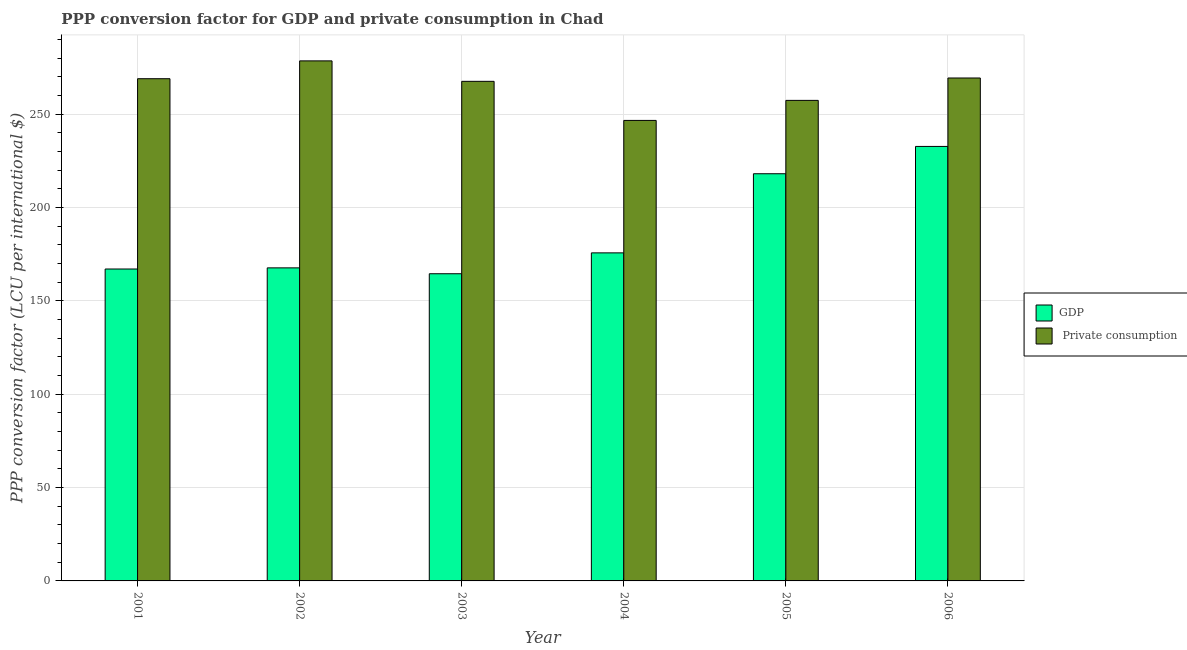How many groups of bars are there?
Provide a succinct answer. 6. Are the number of bars per tick equal to the number of legend labels?
Provide a short and direct response. Yes. How many bars are there on the 5th tick from the right?
Offer a terse response. 2. What is the label of the 1st group of bars from the left?
Offer a very short reply. 2001. What is the ppp conversion factor for gdp in 2005?
Give a very brief answer. 218.09. Across all years, what is the maximum ppp conversion factor for gdp?
Offer a very short reply. 232.72. Across all years, what is the minimum ppp conversion factor for gdp?
Ensure brevity in your answer.  164.53. In which year was the ppp conversion factor for private consumption minimum?
Ensure brevity in your answer.  2004. What is the total ppp conversion factor for gdp in the graph?
Provide a short and direct response. 1125.79. What is the difference between the ppp conversion factor for private consumption in 2001 and that in 2006?
Provide a succinct answer. -0.38. What is the difference between the ppp conversion factor for private consumption in 2003 and the ppp conversion factor for gdp in 2006?
Your answer should be very brief. -1.79. What is the average ppp conversion factor for gdp per year?
Offer a terse response. 187.63. In the year 2001, what is the difference between the ppp conversion factor for private consumption and ppp conversion factor for gdp?
Make the answer very short. 0. In how many years, is the ppp conversion factor for private consumption greater than 270 LCU?
Offer a terse response. 1. What is the ratio of the ppp conversion factor for gdp in 2004 to that in 2005?
Keep it short and to the point. 0.81. Is the ppp conversion factor for gdp in 2005 less than that in 2006?
Make the answer very short. Yes. What is the difference between the highest and the second highest ppp conversion factor for gdp?
Ensure brevity in your answer.  14.63. What is the difference between the highest and the lowest ppp conversion factor for gdp?
Your answer should be compact. 68.19. What does the 1st bar from the left in 2005 represents?
Give a very brief answer. GDP. What does the 1st bar from the right in 2006 represents?
Your response must be concise.  Private consumption. Are the values on the major ticks of Y-axis written in scientific E-notation?
Offer a terse response. No. Where does the legend appear in the graph?
Your response must be concise. Center right. How many legend labels are there?
Your answer should be very brief. 2. What is the title of the graph?
Provide a short and direct response. PPP conversion factor for GDP and private consumption in Chad. What is the label or title of the Y-axis?
Provide a short and direct response. PPP conversion factor (LCU per international $). What is the PPP conversion factor (LCU per international $) in GDP in 2001?
Offer a terse response. 167.06. What is the PPP conversion factor (LCU per international $) of  Private consumption in 2001?
Your answer should be very brief. 269. What is the PPP conversion factor (LCU per international $) of GDP in 2002?
Offer a very short reply. 167.68. What is the PPP conversion factor (LCU per international $) in  Private consumption in 2002?
Provide a succinct answer. 278.54. What is the PPP conversion factor (LCU per international $) in GDP in 2003?
Give a very brief answer. 164.53. What is the PPP conversion factor (LCU per international $) in  Private consumption in 2003?
Your response must be concise. 267.59. What is the PPP conversion factor (LCU per international $) of GDP in 2004?
Give a very brief answer. 175.71. What is the PPP conversion factor (LCU per international $) of  Private consumption in 2004?
Your answer should be compact. 246.65. What is the PPP conversion factor (LCU per international $) in GDP in 2005?
Offer a very short reply. 218.09. What is the PPP conversion factor (LCU per international $) of  Private consumption in 2005?
Offer a very short reply. 257.38. What is the PPP conversion factor (LCU per international $) in GDP in 2006?
Make the answer very short. 232.72. What is the PPP conversion factor (LCU per international $) of  Private consumption in 2006?
Your answer should be very brief. 269.38. Across all years, what is the maximum PPP conversion factor (LCU per international $) of GDP?
Your answer should be very brief. 232.72. Across all years, what is the maximum PPP conversion factor (LCU per international $) of  Private consumption?
Make the answer very short. 278.54. Across all years, what is the minimum PPP conversion factor (LCU per international $) of GDP?
Offer a very short reply. 164.53. Across all years, what is the minimum PPP conversion factor (LCU per international $) in  Private consumption?
Your answer should be compact. 246.65. What is the total PPP conversion factor (LCU per international $) of GDP in the graph?
Offer a terse response. 1125.79. What is the total PPP conversion factor (LCU per international $) in  Private consumption in the graph?
Your response must be concise. 1588.54. What is the difference between the PPP conversion factor (LCU per international $) in GDP in 2001 and that in 2002?
Offer a terse response. -0.61. What is the difference between the PPP conversion factor (LCU per international $) in  Private consumption in 2001 and that in 2002?
Your answer should be compact. -9.55. What is the difference between the PPP conversion factor (LCU per international $) in GDP in 2001 and that in 2003?
Your answer should be very brief. 2.54. What is the difference between the PPP conversion factor (LCU per international $) in  Private consumption in 2001 and that in 2003?
Ensure brevity in your answer.  1.41. What is the difference between the PPP conversion factor (LCU per international $) in GDP in 2001 and that in 2004?
Your answer should be compact. -8.65. What is the difference between the PPP conversion factor (LCU per international $) in  Private consumption in 2001 and that in 2004?
Provide a short and direct response. 22.34. What is the difference between the PPP conversion factor (LCU per international $) in GDP in 2001 and that in 2005?
Give a very brief answer. -51.03. What is the difference between the PPP conversion factor (LCU per international $) in  Private consumption in 2001 and that in 2005?
Keep it short and to the point. 11.61. What is the difference between the PPP conversion factor (LCU per international $) in GDP in 2001 and that in 2006?
Offer a terse response. -65.65. What is the difference between the PPP conversion factor (LCU per international $) of  Private consumption in 2001 and that in 2006?
Keep it short and to the point. -0.38. What is the difference between the PPP conversion factor (LCU per international $) in GDP in 2002 and that in 2003?
Offer a terse response. 3.15. What is the difference between the PPP conversion factor (LCU per international $) of  Private consumption in 2002 and that in 2003?
Your response must be concise. 10.96. What is the difference between the PPP conversion factor (LCU per international $) of GDP in 2002 and that in 2004?
Give a very brief answer. -8.04. What is the difference between the PPP conversion factor (LCU per international $) of  Private consumption in 2002 and that in 2004?
Provide a short and direct response. 31.89. What is the difference between the PPP conversion factor (LCU per international $) in GDP in 2002 and that in 2005?
Give a very brief answer. -50.41. What is the difference between the PPP conversion factor (LCU per international $) of  Private consumption in 2002 and that in 2005?
Your answer should be very brief. 21.16. What is the difference between the PPP conversion factor (LCU per international $) in GDP in 2002 and that in 2006?
Ensure brevity in your answer.  -65.04. What is the difference between the PPP conversion factor (LCU per international $) in  Private consumption in 2002 and that in 2006?
Your answer should be compact. 9.17. What is the difference between the PPP conversion factor (LCU per international $) in GDP in 2003 and that in 2004?
Offer a terse response. -11.18. What is the difference between the PPP conversion factor (LCU per international $) in  Private consumption in 2003 and that in 2004?
Keep it short and to the point. 20.93. What is the difference between the PPP conversion factor (LCU per international $) in GDP in 2003 and that in 2005?
Keep it short and to the point. -53.56. What is the difference between the PPP conversion factor (LCU per international $) in  Private consumption in 2003 and that in 2005?
Keep it short and to the point. 10.2. What is the difference between the PPP conversion factor (LCU per international $) of GDP in 2003 and that in 2006?
Provide a succinct answer. -68.19. What is the difference between the PPP conversion factor (LCU per international $) of  Private consumption in 2003 and that in 2006?
Give a very brief answer. -1.79. What is the difference between the PPP conversion factor (LCU per international $) of GDP in 2004 and that in 2005?
Ensure brevity in your answer.  -42.38. What is the difference between the PPP conversion factor (LCU per international $) in  Private consumption in 2004 and that in 2005?
Keep it short and to the point. -10.73. What is the difference between the PPP conversion factor (LCU per international $) of GDP in 2004 and that in 2006?
Offer a terse response. -57. What is the difference between the PPP conversion factor (LCU per international $) in  Private consumption in 2004 and that in 2006?
Give a very brief answer. -22.72. What is the difference between the PPP conversion factor (LCU per international $) in GDP in 2005 and that in 2006?
Offer a terse response. -14.63. What is the difference between the PPP conversion factor (LCU per international $) in  Private consumption in 2005 and that in 2006?
Offer a very short reply. -11.99. What is the difference between the PPP conversion factor (LCU per international $) of GDP in 2001 and the PPP conversion factor (LCU per international $) of  Private consumption in 2002?
Ensure brevity in your answer.  -111.48. What is the difference between the PPP conversion factor (LCU per international $) of GDP in 2001 and the PPP conversion factor (LCU per international $) of  Private consumption in 2003?
Provide a succinct answer. -100.52. What is the difference between the PPP conversion factor (LCU per international $) of GDP in 2001 and the PPP conversion factor (LCU per international $) of  Private consumption in 2004?
Keep it short and to the point. -79.59. What is the difference between the PPP conversion factor (LCU per international $) in GDP in 2001 and the PPP conversion factor (LCU per international $) in  Private consumption in 2005?
Offer a terse response. -90.32. What is the difference between the PPP conversion factor (LCU per international $) in GDP in 2001 and the PPP conversion factor (LCU per international $) in  Private consumption in 2006?
Offer a very short reply. -102.31. What is the difference between the PPP conversion factor (LCU per international $) of GDP in 2002 and the PPP conversion factor (LCU per international $) of  Private consumption in 2003?
Your answer should be compact. -99.91. What is the difference between the PPP conversion factor (LCU per international $) in GDP in 2002 and the PPP conversion factor (LCU per international $) in  Private consumption in 2004?
Give a very brief answer. -78.98. What is the difference between the PPP conversion factor (LCU per international $) of GDP in 2002 and the PPP conversion factor (LCU per international $) of  Private consumption in 2005?
Your answer should be very brief. -89.71. What is the difference between the PPP conversion factor (LCU per international $) of GDP in 2002 and the PPP conversion factor (LCU per international $) of  Private consumption in 2006?
Offer a terse response. -101.7. What is the difference between the PPP conversion factor (LCU per international $) in GDP in 2003 and the PPP conversion factor (LCU per international $) in  Private consumption in 2004?
Give a very brief answer. -82.12. What is the difference between the PPP conversion factor (LCU per international $) in GDP in 2003 and the PPP conversion factor (LCU per international $) in  Private consumption in 2005?
Offer a terse response. -92.85. What is the difference between the PPP conversion factor (LCU per international $) of GDP in 2003 and the PPP conversion factor (LCU per international $) of  Private consumption in 2006?
Your answer should be very brief. -104.85. What is the difference between the PPP conversion factor (LCU per international $) in GDP in 2004 and the PPP conversion factor (LCU per international $) in  Private consumption in 2005?
Your answer should be very brief. -81.67. What is the difference between the PPP conversion factor (LCU per international $) of GDP in 2004 and the PPP conversion factor (LCU per international $) of  Private consumption in 2006?
Offer a very short reply. -93.66. What is the difference between the PPP conversion factor (LCU per international $) of GDP in 2005 and the PPP conversion factor (LCU per international $) of  Private consumption in 2006?
Ensure brevity in your answer.  -51.29. What is the average PPP conversion factor (LCU per international $) in GDP per year?
Offer a very short reply. 187.63. What is the average PPP conversion factor (LCU per international $) in  Private consumption per year?
Make the answer very short. 264.76. In the year 2001, what is the difference between the PPP conversion factor (LCU per international $) of GDP and PPP conversion factor (LCU per international $) of  Private consumption?
Your response must be concise. -101.93. In the year 2002, what is the difference between the PPP conversion factor (LCU per international $) of GDP and PPP conversion factor (LCU per international $) of  Private consumption?
Ensure brevity in your answer.  -110.87. In the year 2003, what is the difference between the PPP conversion factor (LCU per international $) in GDP and PPP conversion factor (LCU per international $) in  Private consumption?
Offer a very short reply. -103.06. In the year 2004, what is the difference between the PPP conversion factor (LCU per international $) of GDP and PPP conversion factor (LCU per international $) of  Private consumption?
Your response must be concise. -70.94. In the year 2005, what is the difference between the PPP conversion factor (LCU per international $) in GDP and PPP conversion factor (LCU per international $) in  Private consumption?
Offer a very short reply. -39.29. In the year 2006, what is the difference between the PPP conversion factor (LCU per international $) of GDP and PPP conversion factor (LCU per international $) of  Private consumption?
Your answer should be very brief. -36.66. What is the ratio of the PPP conversion factor (LCU per international $) in  Private consumption in 2001 to that in 2002?
Offer a very short reply. 0.97. What is the ratio of the PPP conversion factor (LCU per international $) of GDP in 2001 to that in 2003?
Provide a succinct answer. 1.02. What is the ratio of the PPP conversion factor (LCU per international $) in  Private consumption in 2001 to that in 2003?
Make the answer very short. 1.01. What is the ratio of the PPP conversion factor (LCU per international $) of GDP in 2001 to that in 2004?
Your answer should be very brief. 0.95. What is the ratio of the PPP conversion factor (LCU per international $) in  Private consumption in 2001 to that in 2004?
Offer a very short reply. 1.09. What is the ratio of the PPP conversion factor (LCU per international $) in GDP in 2001 to that in 2005?
Provide a succinct answer. 0.77. What is the ratio of the PPP conversion factor (LCU per international $) of  Private consumption in 2001 to that in 2005?
Your response must be concise. 1.05. What is the ratio of the PPP conversion factor (LCU per international $) of GDP in 2001 to that in 2006?
Ensure brevity in your answer.  0.72. What is the ratio of the PPP conversion factor (LCU per international $) of  Private consumption in 2001 to that in 2006?
Provide a succinct answer. 1. What is the ratio of the PPP conversion factor (LCU per international $) of GDP in 2002 to that in 2003?
Ensure brevity in your answer.  1.02. What is the ratio of the PPP conversion factor (LCU per international $) in  Private consumption in 2002 to that in 2003?
Make the answer very short. 1.04. What is the ratio of the PPP conversion factor (LCU per international $) in GDP in 2002 to that in 2004?
Give a very brief answer. 0.95. What is the ratio of the PPP conversion factor (LCU per international $) of  Private consumption in 2002 to that in 2004?
Your response must be concise. 1.13. What is the ratio of the PPP conversion factor (LCU per international $) of GDP in 2002 to that in 2005?
Keep it short and to the point. 0.77. What is the ratio of the PPP conversion factor (LCU per international $) of  Private consumption in 2002 to that in 2005?
Keep it short and to the point. 1.08. What is the ratio of the PPP conversion factor (LCU per international $) in GDP in 2002 to that in 2006?
Keep it short and to the point. 0.72. What is the ratio of the PPP conversion factor (LCU per international $) in  Private consumption in 2002 to that in 2006?
Provide a short and direct response. 1.03. What is the ratio of the PPP conversion factor (LCU per international $) of GDP in 2003 to that in 2004?
Offer a terse response. 0.94. What is the ratio of the PPP conversion factor (LCU per international $) in  Private consumption in 2003 to that in 2004?
Offer a terse response. 1.08. What is the ratio of the PPP conversion factor (LCU per international $) in GDP in 2003 to that in 2005?
Your answer should be compact. 0.75. What is the ratio of the PPP conversion factor (LCU per international $) of  Private consumption in 2003 to that in 2005?
Provide a succinct answer. 1.04. What is the ratio of the PPP conversion factor (LCU per international $) of GDP in 2003 to that in 2006?
Offer a very short reply. 0.71. What is the ratio of the PPP conversion factor (LCU per international $) in GDP in 2004 to that in 2005?
Give a very brief answer. 0.81. What is the ratio of the PPP conversion factor (LCU per international $) of GDP in 2004 to that in 2006?
Provide a succinct answer. 0.76. What is the ratio of the PPP conversion factor (LCU per international $) of  Private consumption in 2004 to that in 2006?
Provide a short and direct response. 0.92. What is the ratio of the PPP conversion factor (LCU per international $) in GDP in 2005 to that in 2006?
Give a very brief answer. 0.94. What is the ratio of the PPP conversion factor (LCU per international $) of  Private consumption in 2005 to that in 2006?
Provide a succinct answer. 0.96. What is the difference between the highest and the second highest PPP conversion factor (LCU per international $) of GDP?
Provide a succinct answer. 14.63. What is the difference between the highest and the second highest PPP conversion factor (LCU per international $) of  Private consumption?
Offer a terse response. 9.17. What is the difference between the highest and the lowest PPP conversion factor (LCU per international $) in GDP?
Make the answer very short. 68.19. What is the difference between the highest and the lowest PPP conversion factor (LCU per international $) of  Private consumption?
Provide a short and direct response. 31.89. 